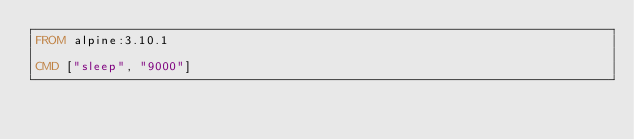<code> <loc_0><loc_0><loc_500><loc_500><_Dockerfile_>FROM alpine:3.10.1

CMD ["sleep", "9000"]</code> 